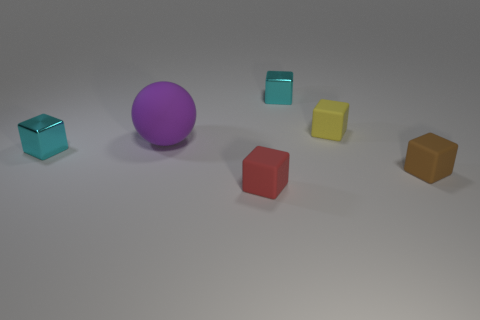Is the purple sphere made of the same material as the small cyan cube that is on the right side of the red matte object?
Give a very brief answer. No. Are there any other things that have the same size as the brown matte block?
Make the answer very short. Yes. How many objects are yellow matte blocks or blocks in front of the large purple matte thing?
Ensure brevity in your answer.  4. There is a cyan metallic block to the right of the red matte cube; does it have the same size as the metal thing that is in front of the ball?
Keep it short and to the point. Yes. How many other objects are there of the same color as the ball?
Make the answer very short. 0. Does the rubber sphere have the same size as the cyan shiny object behind the small yellow object?
Offer a terse response. No. There is a shiny block that is in front of the cyan metal cube behind the big purple matte ball; how big is it?
Offer a terse response. Small. Do the red matte object and the brown object have the same size?
Your answer should be very brief. Yes. Are there the same number of cyan things that are in front of the yellow rubber cube and red matte things?
Your answer should be very brief. Yes. There is a cyan metallic thing that is to the right of the red object; is there a small red matte cube on the right side of it?
Offer a terse response. No. 